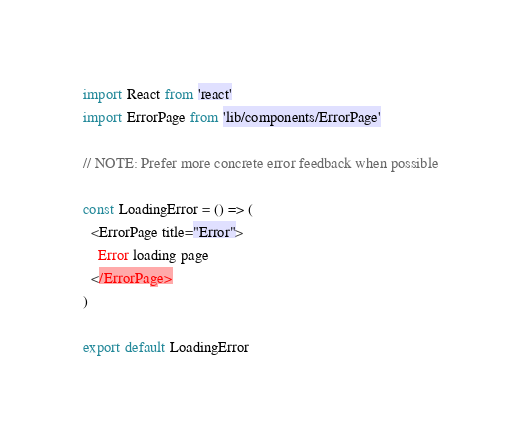Convert code to text. <code><loc_0><loc_0><loc_500><loc_500><_JavaScript_>import React from 'react'
import ErrorPage from 'lib/components/ErrorPage'

// NOTE: Prefer more concrete error feedback when possible

const LoadingError = () => (
  <ErrorPage title="Error">
    Error loading page
  </ErrorPage>
)

export default LoadingError
</code> 